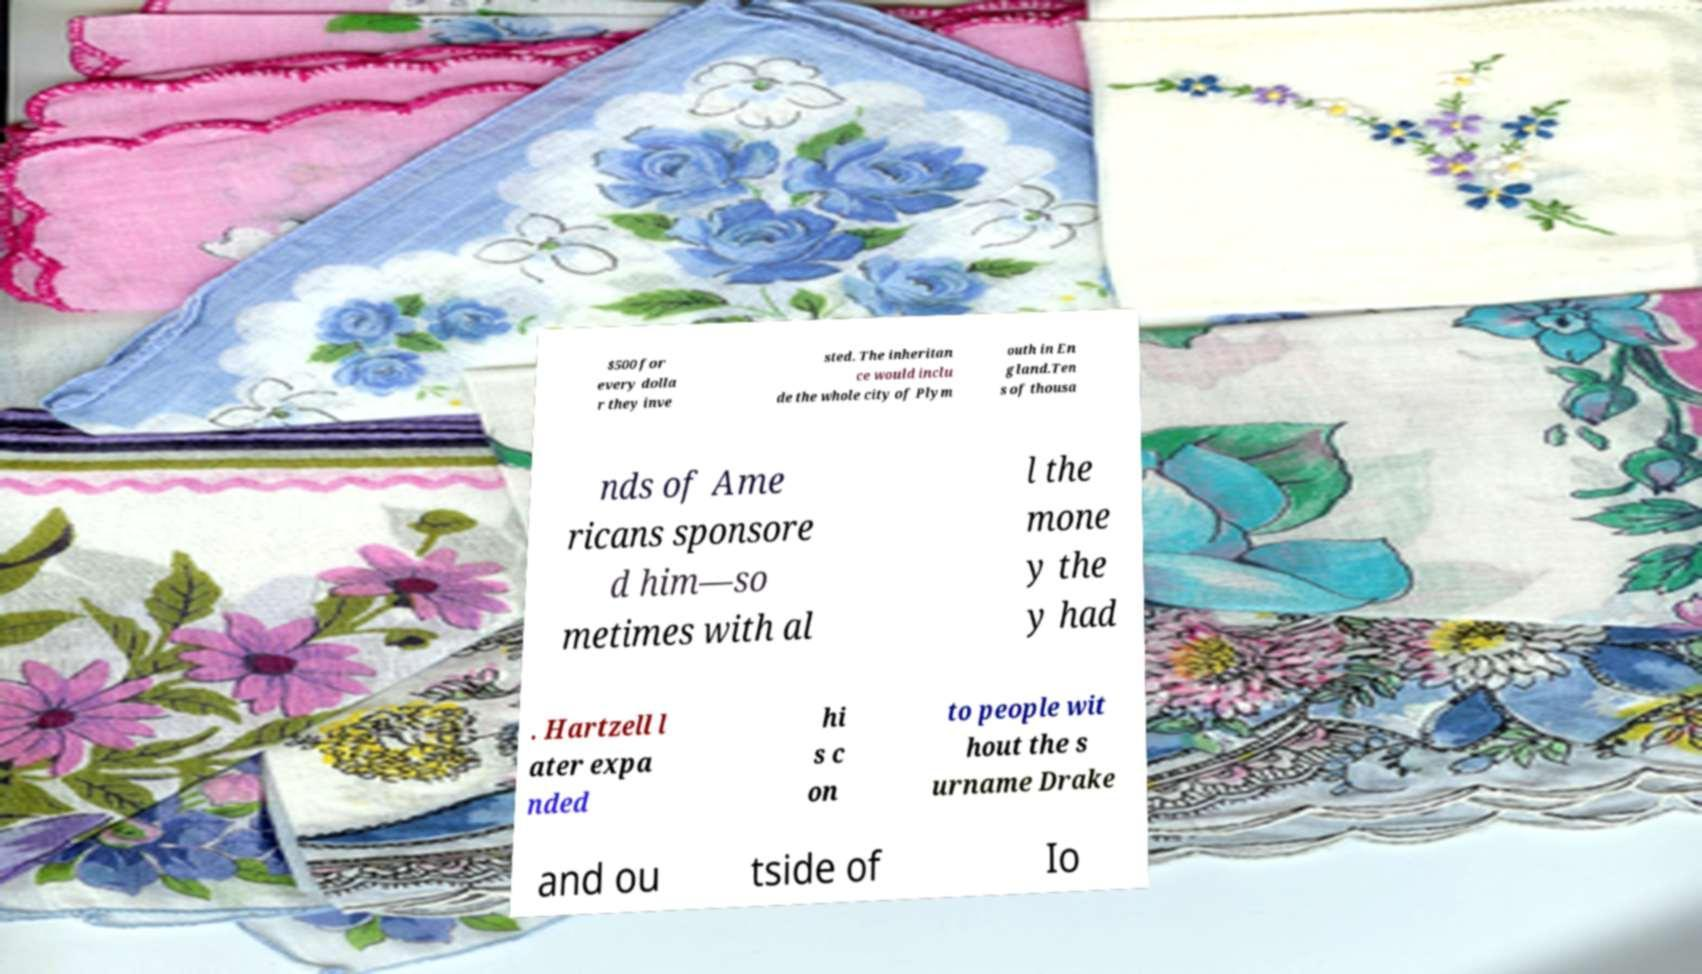Please identify and transcribe the text found in this image. $500 for every dolla r they inve sted. The inheritan ce would inclu de the whole city of Plym outh in En gland.Ten s of thousa nds of Ame ricans sponsore d him—so metimes with al l the mone y the y had . Hartzell l ater expa nded hi s c on to people wit hout the s urname Drake and ou tside of Io 